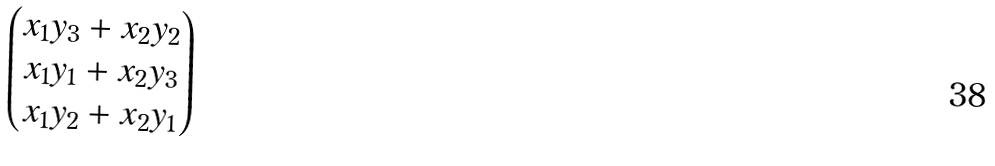Convert formula to latex. <formula><loc_0><loc_0><loc_500><loc_500>\begin{pmatrix} x _ { 1 } y _ { 3 } + x _ { 2 } y _ { 2 } \\ x _ { 1 } y _ { 1 } + x _ { 2 } y _ { 3 } \\ x _ { 1 } y _ { 2 } + x _ { 2 } y _ { 1 } \end{pmatrix}</formula> 